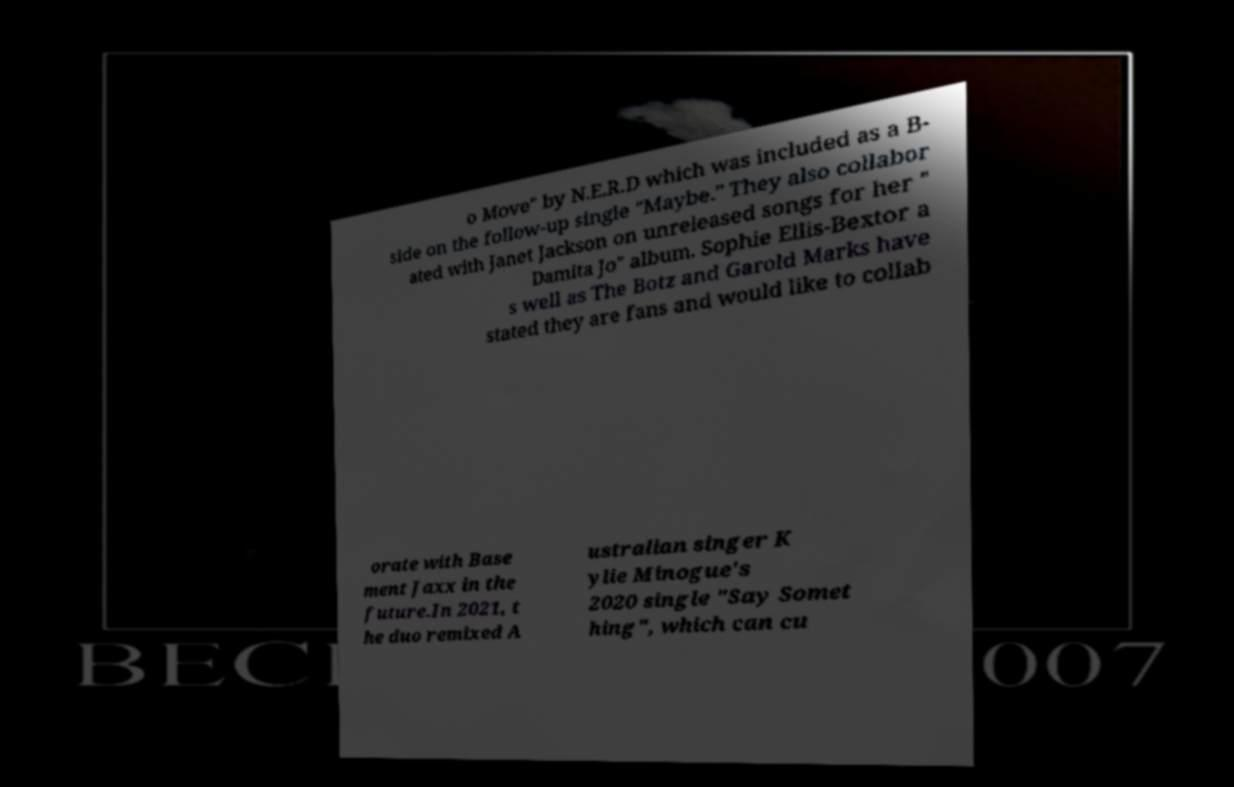Can you read and provide the text displayed in the image?This photo seems to have some interesting text. Can you extract and type it out for me? o Move" by N.E.R.D which was included as a B- side on the follow-up single "Maybe." They also collabor ated with Janet Jackson on unreleased songs for her " Damita Jo" album. Sophie Ellis-Bextor a s well as The Botz and Garold Marks have stated they are fans and would like to collab orate with Base ment Jaxx in the future.In 2021, t he duo remixed A ustralian singer K ylie Minogue's 2020 single "Say Somet hing", which can cu 